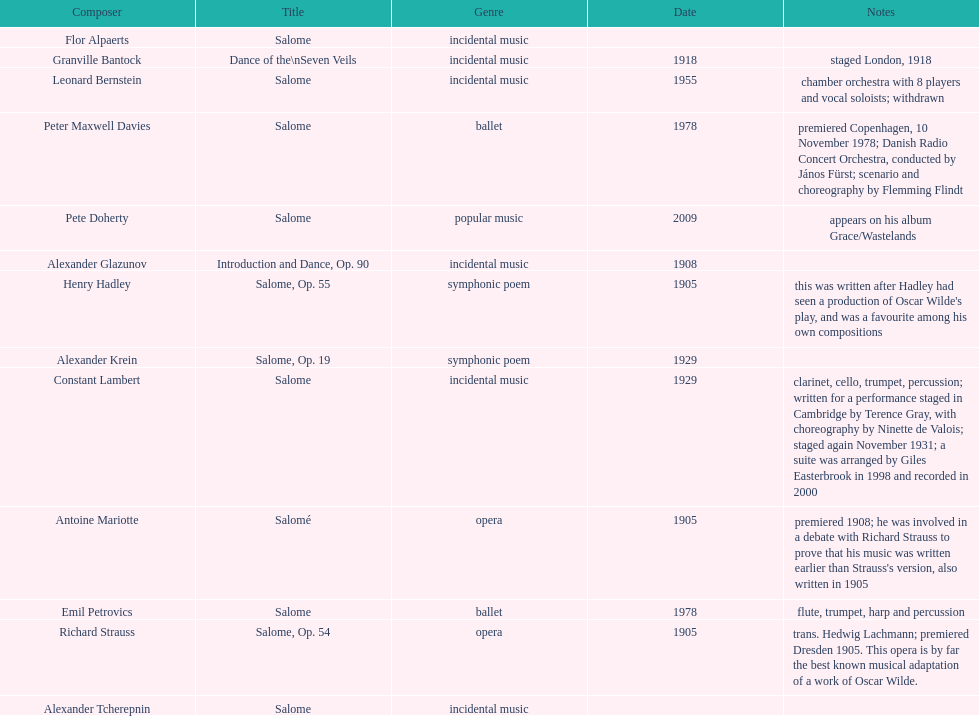Who is following alexander krein on the list? Constant Lambert. 